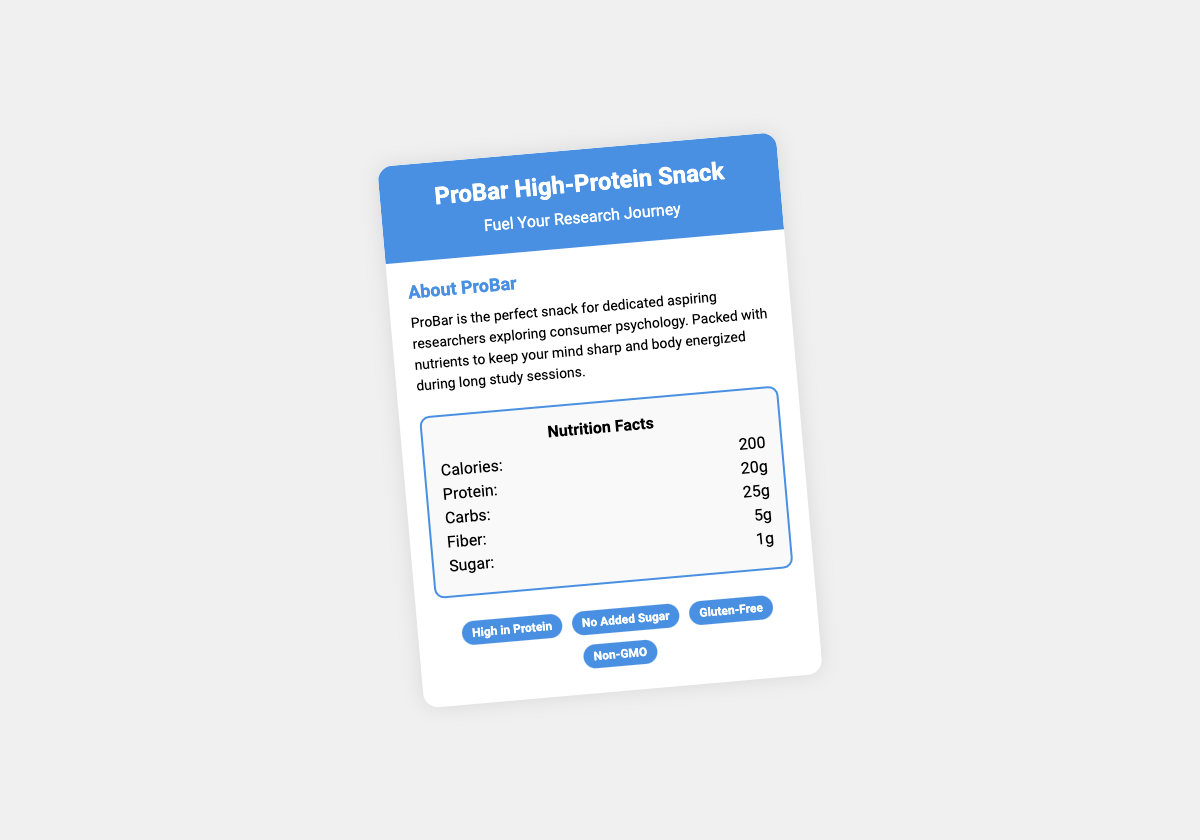What is the total calorie count? The total calorie count is stated in the nutritional facts section of the document.
Answer: 200 How much protein does the ProBar contain? The protein content is specified in the nutrition facts section.
Answer: 20g What health claim indicates that the product has no added sugar? The health claim section lists various claims, including the one for no added sugar.
Answer: No Added Sugar How many grams of sugar are in the ProBar? The amount of sugar is listed in the nutrition facts of the document.
Answer: 1g What is the purpose of ProBar according to the document? The document explains the purpose in the "About ProBar" section.
Answer: Fuel Your Research Journey Is the ProBar gluten-free? This is a health claim stated in the document, confirming it meets gluten-free standards.
Answer: Yes What is the total carbohydrate content? The total amount of carbohydrates is provided in the nutrition facts.
Answer: 25g Which specific audience does the ProBar target? The document mentions the target audience in the "About ProBar" section.
Answer: Dedicated aspiring researchers How many grams of fiber are in this snack bar? The fiber content is listed under the nutrition facts of the ProBar.
Answer: 5g 